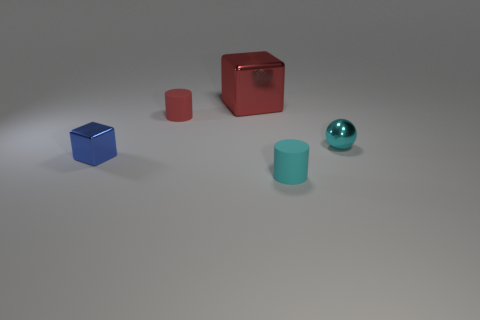Are the tiny object that is in front of the small cube and the small cyan sphere made of the same material?
Your response must be concise. No. Are any red metal blocks visible?
Offer a very short reply. Yes. There is a tiny thing that is made of the same material as the cyan sphere; what color is it?
Give a very brief answer. Blue. There is a rubber cylinder on the left side of the metal object behind the small matte cylinder that is behind the tiny cube; what is its color?
Offer a terse response. Red. Do the cyan cylinder and the metal thing on the right side of the large red thing have the same size?
Give a very brief answer. Yes. How many objects are either cylinders that are in front of the tiny blue thing or cyan objects in front of the blue shiny object?
Offer a very short reply. 1. What is the shape of the cyan object that is the same size as the cyan cylinder?
Ensure brevity in your answer.  Sphere. What shape is the matte object in front of the tiny cylinder left of the cylinder in front of the tiny red object?
Make the answer very short. Cylinder. Is the number of big red shiny things that are to the right of the cyan rubber object the same as the number of yellow cylinders?
Provide a succinct answer. Yes. Do the cyan sphere and the blue metallic thing have the same size?
Offer a terse response. Yes. 